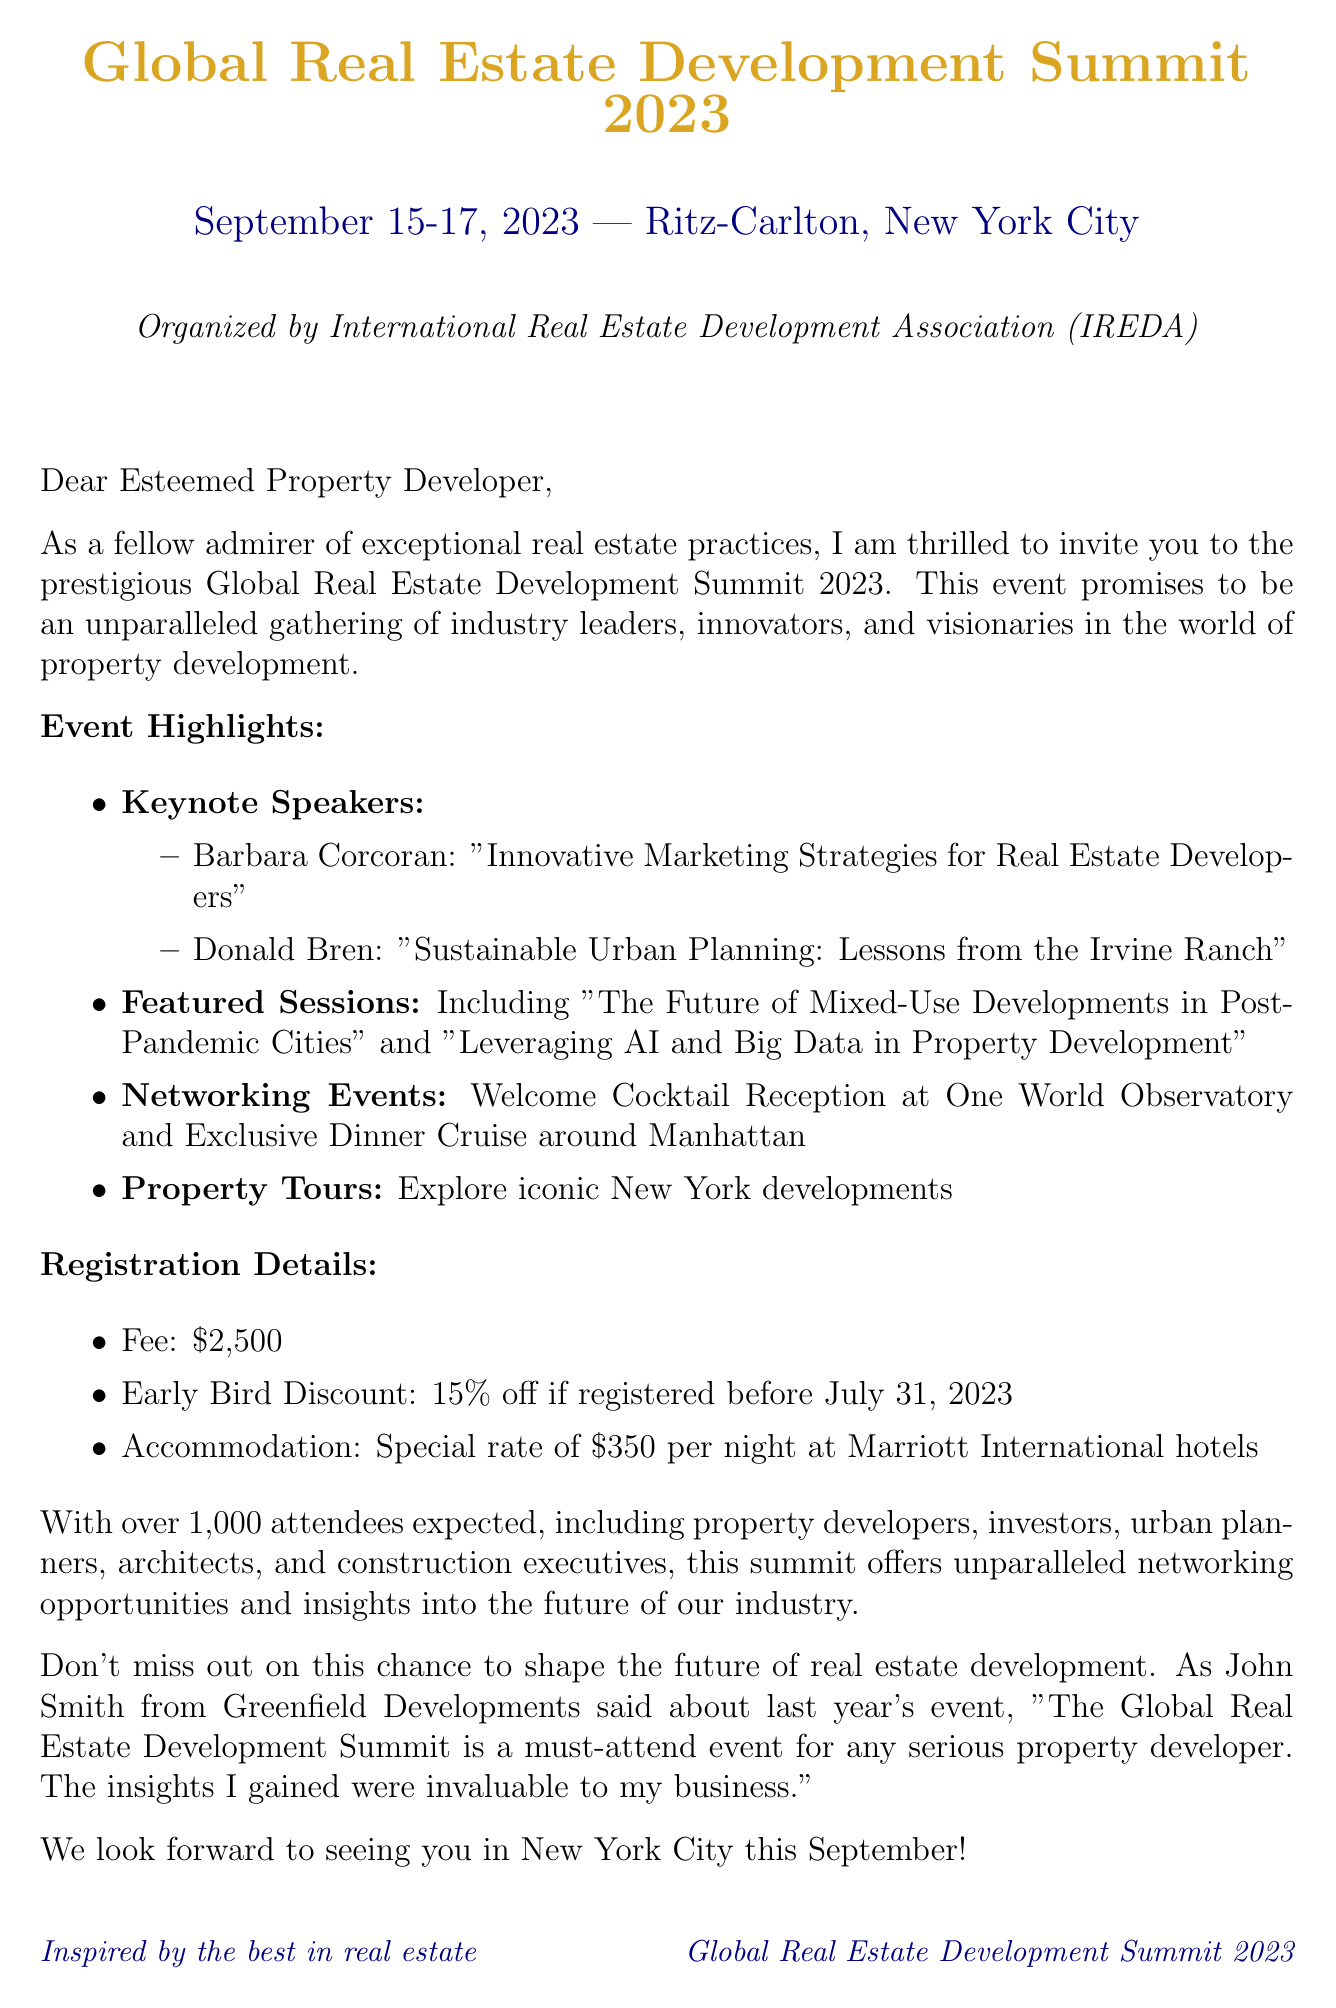What is the conference name? The conference name is mentioned in the introduction of the document, which is "Global Real Estate Development Summit 2023".
Answer: Global Real Estate Development Summit 2023 When is the conference scheduled? The date can be found under the conference details, specifically listed as "September 15-17, 2023".
Answer: September 15-17, 2023 Who is one of the keynote speakers? Keynote speakers are listed in the event highlights, where "Barbara Corcoran" is mentioned.
Answer: Barbara Corcoran What is the registration fee for the conference? The registration fee is explicitly stated in the registration details section as "$2,500".
Answer: $2,500 What discount is offered for early bird registrations? The early bird discount percentage is given in the registration details, which is "15% off if registered before July 31, 2023".
Answer: 15% off What type of networking events are included? Networking events are briefly described in the highlights, one of which is the "Welcome Cocktail Reception at One World Observatory".
Answer: Welcome Cocktail Reception at One World Observatory How many attendees are expected at the conference? The expected number of attendees is highlighted in the document, mentioned as "1000".
Answer: 1000 What is the special hotel rate per night? The accommodation details specify the rate per night, which is "$350 per night".
Answer: $350 per night What did John Smith say about last year's event? A testimonial section includes a quote from John Smith, which adds credibility to the event and his statement is included in the letter.
Answer: "The Global Real Estate Development Summit is a must-attend event for any serious property developer." 